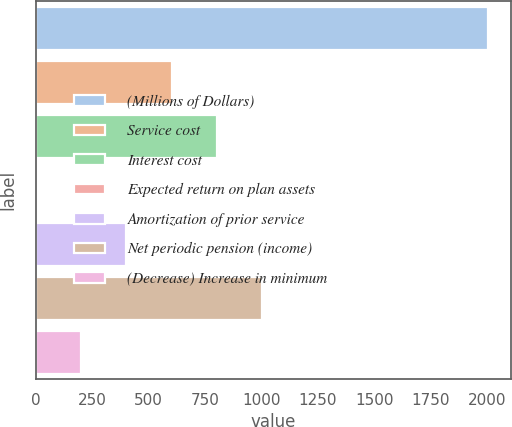<chart> <loc_0><loc_0><loc_500><loc_500><bar_chart><fcel>(Millions of Dollars)<fcel>Service cost<fcel>Interest cost<fcel>Expected return on plan assets<fcel>Amortization of prior service<fcel>Net periodic pension (income)<fcel>(Decrease) Increase in minimum<nl><fcel>2004<fcel>601.9<fcel>802.2<fcel>1<fcel>401.6<fcel>1002.5<fcel>201.3<nl></chart> 